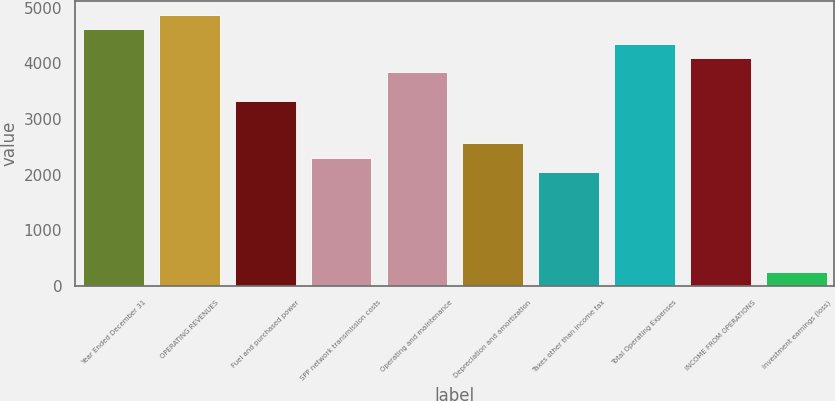Convert chart to OTSL. <chart><loc_0><loc_0><loc_500><loc_500><bar_chart><fcel>Year Ended December 31<fcel>OPERATING REVENUES<fcel>Fuel and purchased power<fcel>SPP network transmission costs<fcel>Operating and maintenance<fcel>Depreciation and amortization<fcel>Taxes other than income tax<fcel>Total Operating Expenses<fcel>INCOME FROM OPERATIONS<fcel>Investment earnings (loss)<nl><fcel>4610.58<fcel>4866.64<fcel>3330.28<fcel>2306.04<fcel>3842.4<fcel>2562.1<fcel>2049.98<fcel>4354.52<fcel>4098.46<fcel>257.56<nl></chart> 